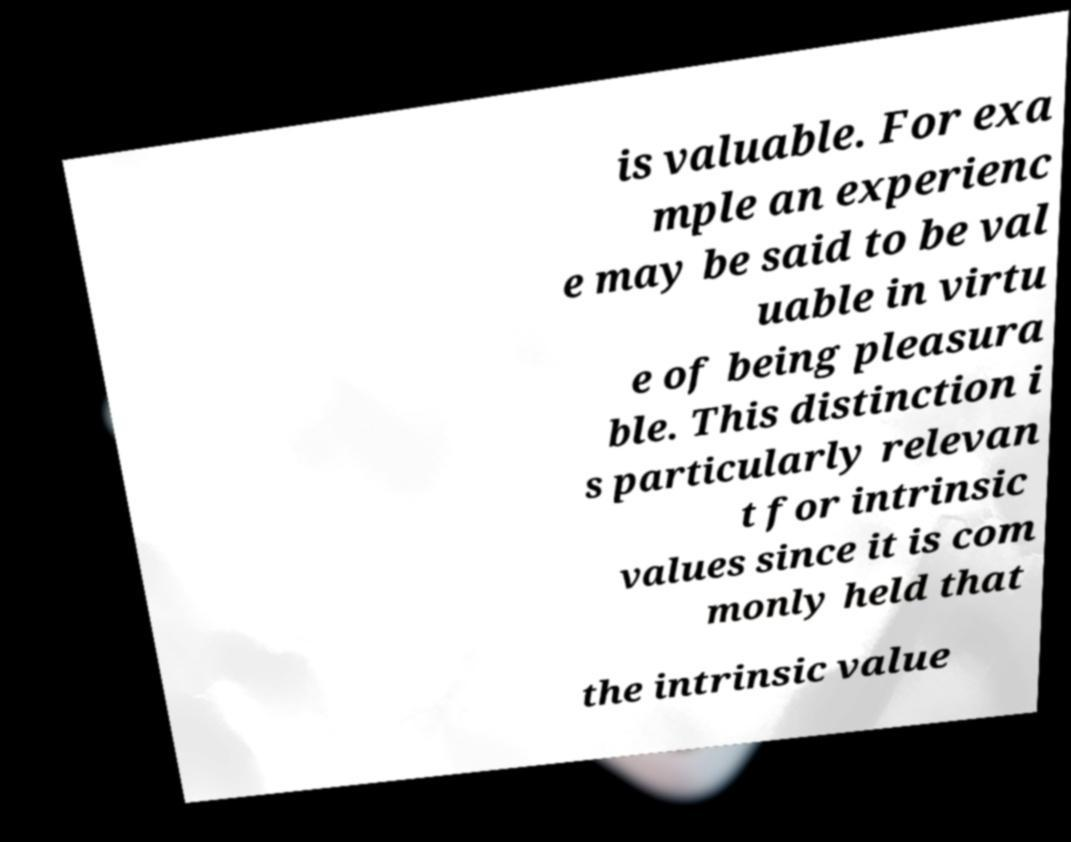Can you accurately transcribe the text from the provided image for me? is valuable. For exa mple an experienc e may be said to be val uable in virtu e of being pleasura ble. This distinction i s particularly relevan t for intrinsic values since it is com monly held that the intrinsic value 